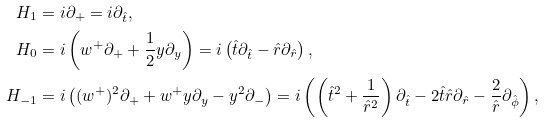<formula> <loc_0><loc_0><loc_500><loc_500>H _ { 1 } & = i \partial _ { + } = i \partial _ { \hat { t } } , \\ H _ { 0 } & = i \left ( w ^ { + } \partial _ { + } + \frac { 1 } { 2 } y \partial _ { y } \right ) = i \left ( \hat { t } \partial _ { \hat { t } } - \hat { r } \partial _ { \hat { r } } \right ) , \\ H _ { - 1 } & = i \left ( ( w ^ { + } ) ^ { 2 } \partial _ { + } + w ^ { + } y \partial _ { y } - y ^ { 2 } \partial _ { - } \right ) = i \left ( \left ( \hat { t } ^ { 2 } + \frac { 1 } { \hat { r } ^ { 2 } } \right ) \partial _ { \hat { t } } - 2 \hat { t } \hat { r } \partial _ { \hat { r } } - \frac { 2 } { \hat { r } } \partial _ { \hat { \phi } } \right ) ,</formula> 